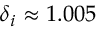<formula> <loc_0><loc_0><loc_500><loc_500>\delta _ { i } \approx 1 . 0 0 5</formula> 